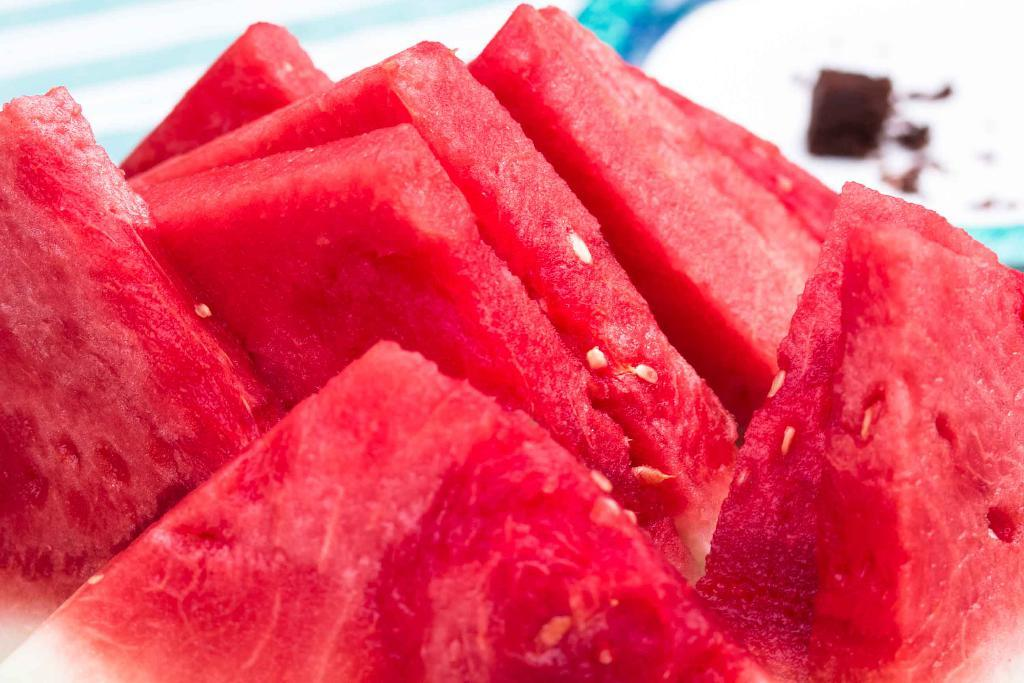What type of food items are present in the image? There are fruits in the image. What color are the fruits? The fruits are in red color. What is the color of the background in the image? The background of the image is white. What type of brain can be seen in the image? There is no brain present in the image; it features red fruits against a white background. Is there a scarf visible in the image? No, there is no scarf present in the image. 